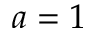Convert formula to latex. <formula><loc_0><loc_0><loc_500><loc_500>a = 1</formula> 